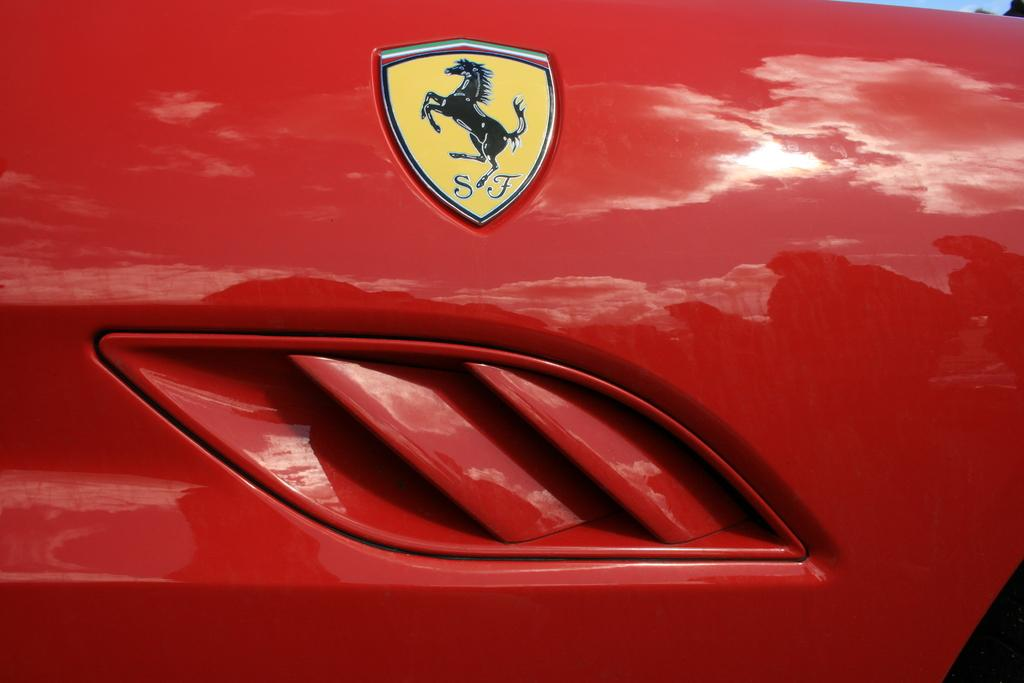What is the main subject of the image? The main subject of the image is a logo of a vehicle. What type of page is being used to display the logo in the image? There is no reference to a page in the image, as it only features a logo of a vehicle. 